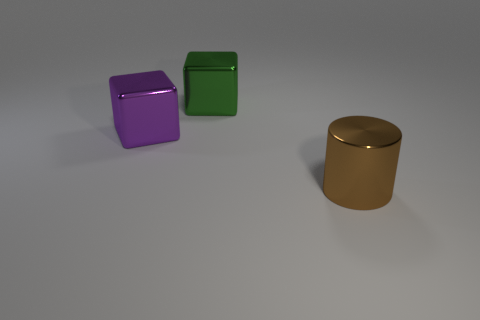Is the size of the brown thing the same as the purple metallic block?
Provide a short and direct response. Yes. Are there more large purple shiny objects than red metal cylinders?
Your response must be concise. Yes. The metal block to the right of the block left of the thing that is behind the purple object is what color?
Offer a terse response. Green. Do the big thing right of the big green shiny cube and the green object have the same shape?
Keep it short and to the point. No. There is a metal block that is the same size as the green metal thing; what color is it?
Offer a very short reply. Purple. What number of large brown metal balls are there?
Offer a very short reply. 0. Are the big thing that is to the left of the green block and the large brown cylinder made of the same material?
Give a very brief answer. Yes. There is a large block to the right of the large shiny cube that is in front of the big green cube; what is it made of?
Provide a short and direct response. Metal. What is the size of the shiny cube left of the big block that is right of the large purple metallic cube that is in front of the green thing?
Your answer should be compact. Large. How many brown things are the same material as the large purple cube?
Your response must be concise. 1. 